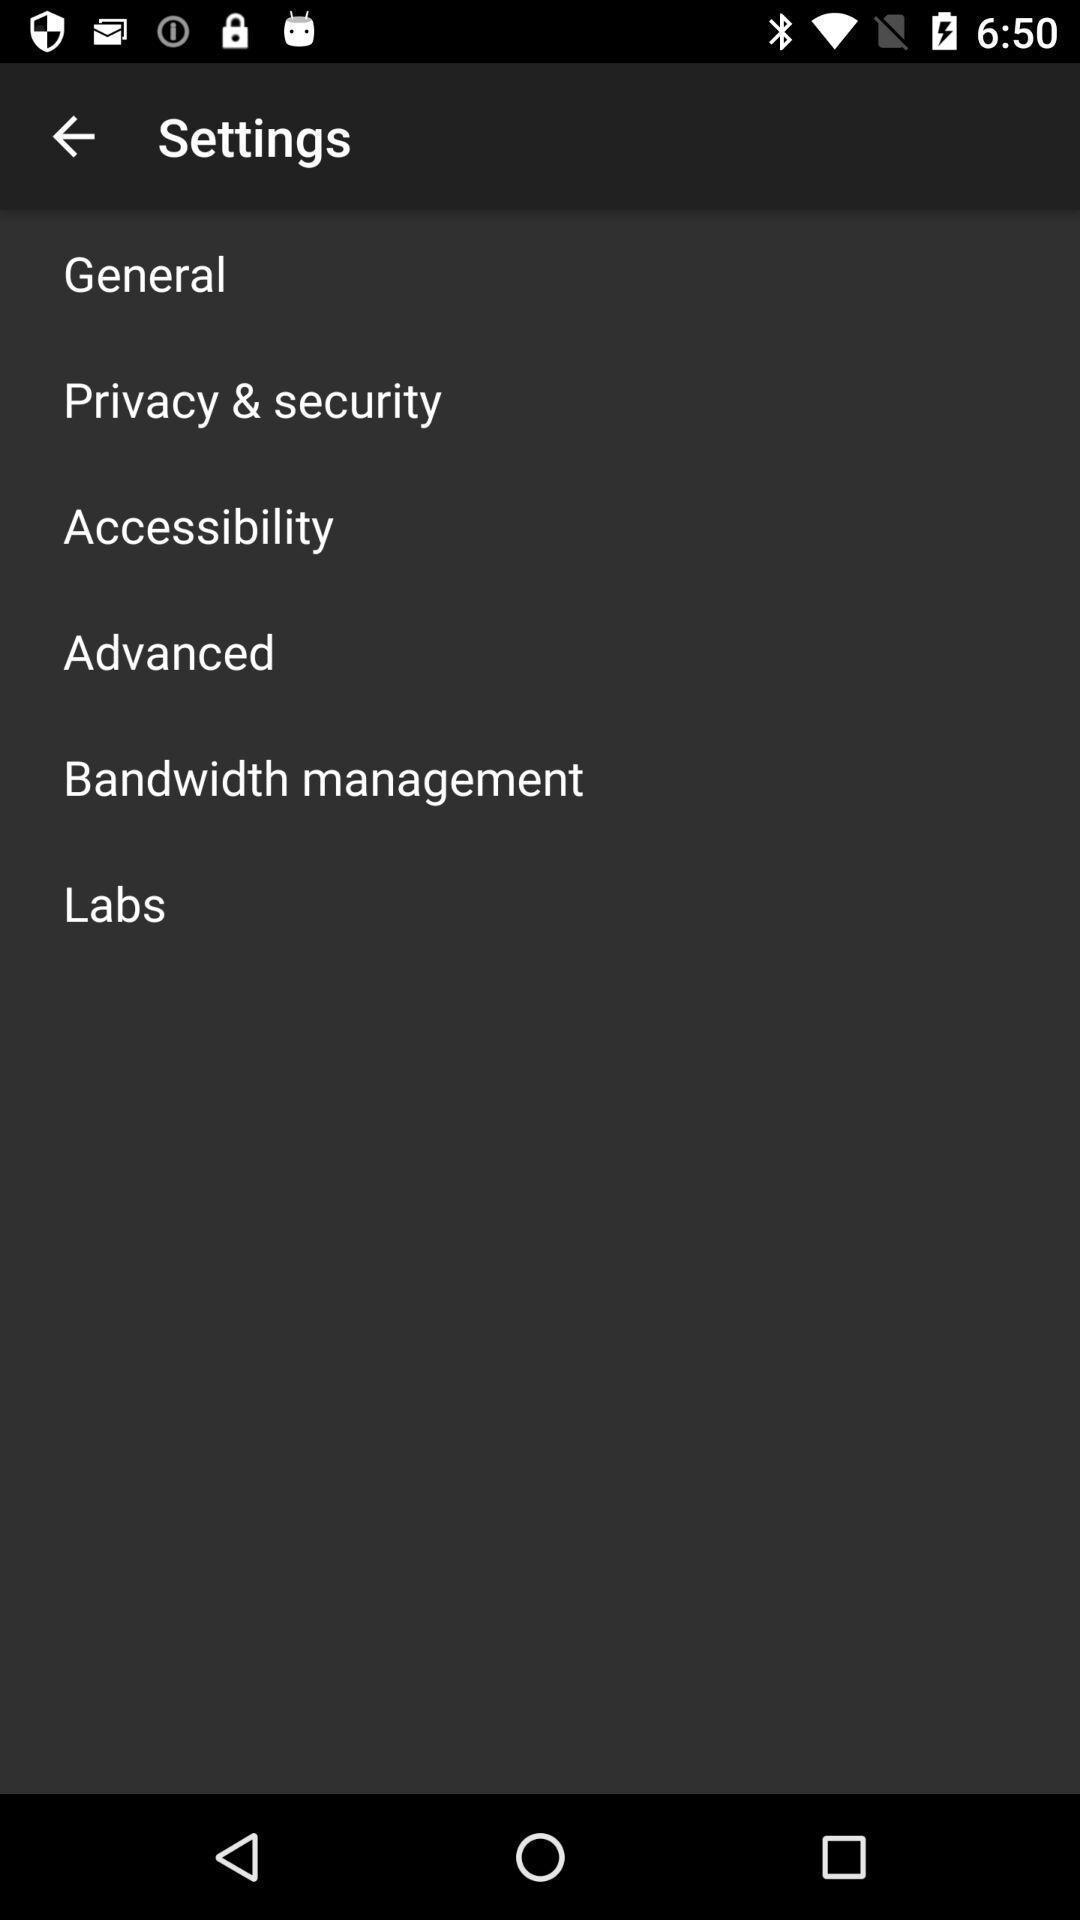Give me a narrative description of this picture. Screen shows settings. 